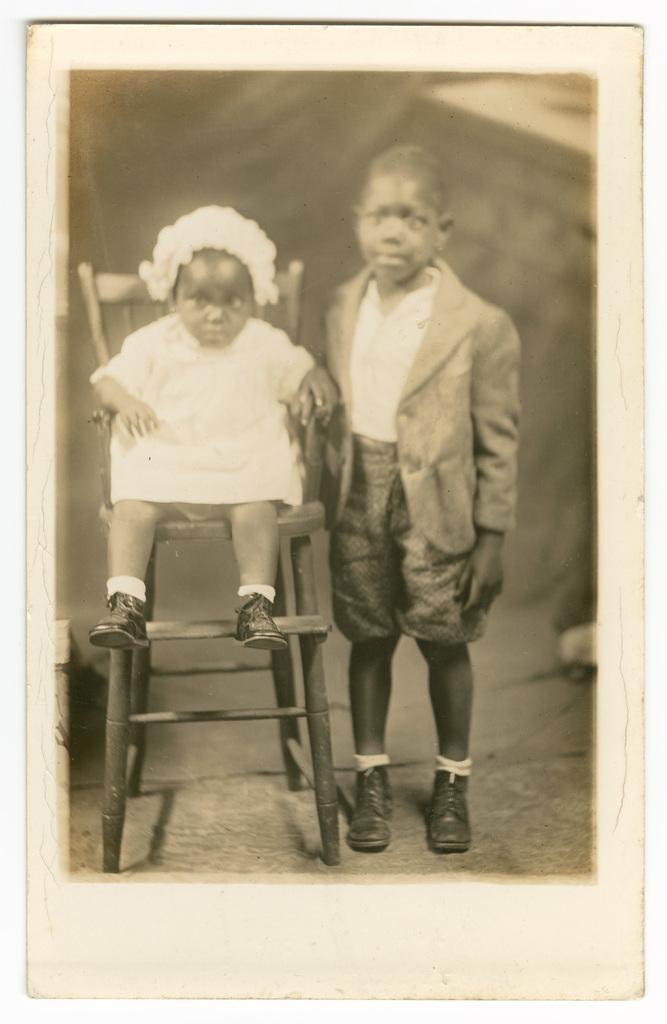Describe this image in one or two sentences. In this picture we can see a child on a chair. There is a boy on standing on the path. 